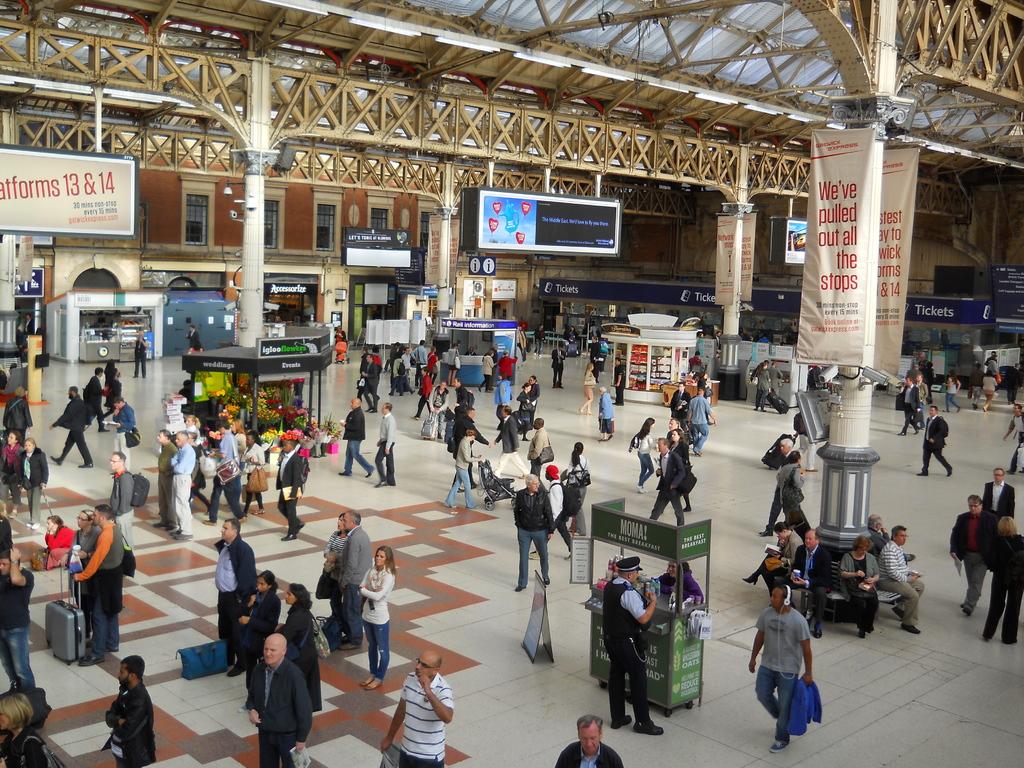What platforms are mentioned on the banner on the left?
Provide a short and direct response. 13 & 14. Which platforms are listed in the top left corner?
Provide a succinct answer. 13 & 14. 